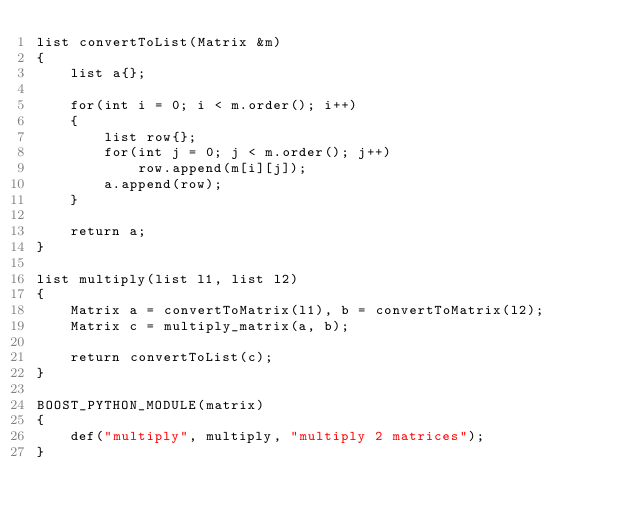Convert code to text. <code><loc_0><loc_0><loc_500><loc_500><_Cuda_>list convertToList(Matrix &m)
{
    list a{};

    for(int i = 0; i < m.order(); i++)
    {
        list row{};
        for(int j = 0; j < m.order(); j++)
            row.append(m[i][j]);
        a.append(row);
    }

    return a;
}

list multiply(list l1, list l2)
{
    Matrix a = convertToMatrix(l1), b = convertToMatrix(l2);
    Matrix c = multiply_matrix(a, b);

    return convertToList(c);
}

BOOST_PYTHON_MODULE(matrix)
{
    def("multiply", multiply, "multiply 2 matrices");
}</code> 